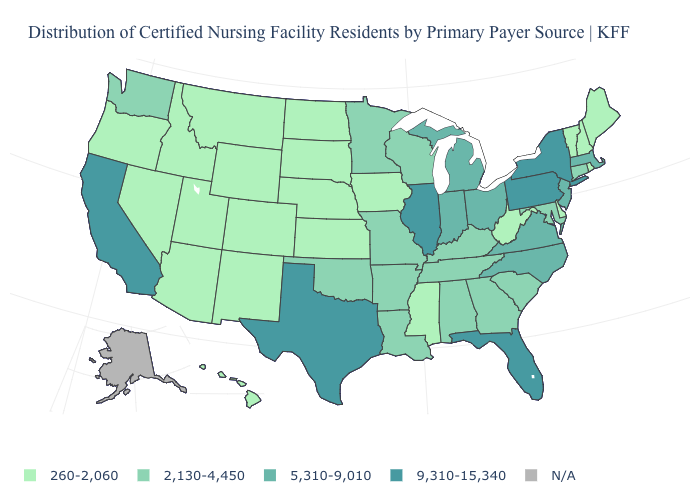Does the first symbol in the legend represent the smallest category?
Concise answer only. Yes. What is the value of Rhode Island?
Short answer required. 260-2,060. What is the value of North Carolina?
Keep it brief. 5,310-9,010. What is the lowest value in the USA?
Concise answer only. 260-2,060. Does the map have missing data?
Write a very short answer. Yes. Name the states that have a value in the range 5,310-9,010?
Short answer required. Indiana, Massachusetts, Michigan, New Jersey, North Carolina, Ohio, Virginia. What is the value of Louisiana?
Concise answer only. 2,130-4,450. What is the value of Maryland?
Answer briefly. 2,130-4,450. Name the states that have a value in the range 2,130-4,450?
Answer briefly. Alabama, Arkansas, Connecticut, Georgia, Kentucky, Louisiana, Maryland, Minnesota, Missouri, Oklahoma, South Carolina, Tennessee, Washington, Wisconsin. What is the highest value in the USA?
Be succinct. 9,310-15,340. Does Wyoming have the lowest value in the USA?
Quick response, please. Yes. Is the legend a continuous bar?
Concise answer only. No. Among the states that border Connecticut , does Rhode Island have the lowest value?
Answer briefly. Yes. Among the states that border Georgia , which have the highest value?
Quick response, please. Florida. 